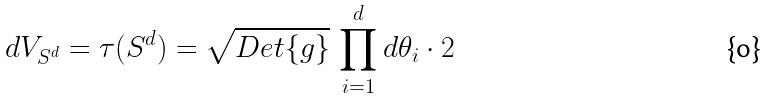Convert formula to latex. <formula><loc_0><loc_0><loc_500><loc_500>d V _ { S ^ { d } } = \tau ( S ^ { d } ) = \sqrt { D e t \{ g \} } \, \prod _ { i = 1 } ^ { d } d \theta _ { i } \cdot 2</formula> 